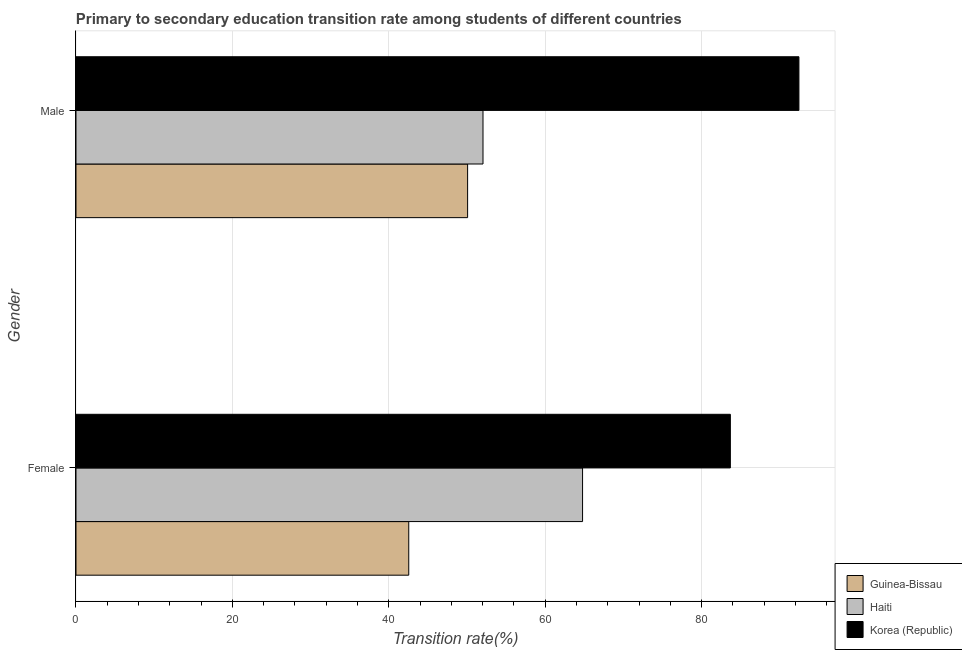Are the number of bars per tick equal to the number of legend labels?
Your answer should be compact. Yes. What is the transition rate among male students in Haiti?
Provide a succinct answer. 52.04. Across all countries, what is the maximum transition rate among male students?
Make the answer very short. 92.44. Across all countries, what is the minimum transition rate among female students?
Give a very brief answer. 42.55. In which country was the transition rate among male students minimum?
Provide a succinct answer. Guinea-Bissau. What is the total transition rate among female students in the graph?
Offer a very short reply. 191. What is the difference between the transition rate among male students in Korea (Republic) and that in Guinea-Bissau?
Offer a very short reply. 42.36. What is the difference between the transition rate among female students in Haiti and the transition rate among male students in Guinea-Bissau?
Provide a short and direct response. 14.7. What is the average transition rate among female students per country?
Make the answer very short. 63.67. What is the difference between the transition rate among female students and transition rate among male students in Korea (Republic)?
Make the answer very short. -8.77. What is the ratio of the transition rate among male students in Guinea-Bissau to that in Korea (Republic)?
Your response must be concise. 0.54. What does the 3rd bar from the top in Female represents?
Keep it short and to the point. Guinea-Bissau. How many bars are there?
Your answer should be very brief. 6. Are all the bars in the graph horizontal?
Provide a succinct answer. Yes. Does the graph contain any zero values?
Provide a short and direct response. No. Where does the legend appear in the graph?
Offer a terse response. Bottom right. How many legend labels are there?
Keep it short and to the point. 3. How are the legend labels stacked?
Give a very brief answer. Vertical. What is the title of the graph?
Your answer should be very brief. Primary to secondary education transition rate among students of different countries. Does "Iraq" appear as one of the legend labels in the graph?
Your answer should be compact. No. What is the label or title of the X-axis?
Your answer should be compact. Transition rate(%). What is the Transition rate(%) in Guinea-Bissau in Female?
Your answer should be compact. 42.55. What is the Transition rate(%) in Haiti in Female?
Ensure brevity in your answer.  64.77. What is the Transition rate(%) in Korea (Republic) in Female?
Give a very brief answer. 83.67. What is the Transition rate(%) of Guinea-Bissau in Male?
Provide a short and direct response. 50.08. What is the Transition rate(%) of Haiti in Male?
Offer a very short reply. 52.04. What is the Transition rate(%) of Korea (Republic) in Male?
Keep it short and to the point. 92.44. Across all Gender, what is the maximum Transition rate(%) in Guinea-Bissau?
Your answer should be very brief. 50.08. Across all Gender, what is the maximum Transition rate(%) of Haiti?
Your answer should be compact. 64.77. Across all Gender, what is the maximum Transition rate(%) in Korea (Republic)?
Your answer should be very brief. 92.44. Across all Gender, what is the minimum Transition rate(%) in Guinea-Bissau?
Provide a short and direct response. 42.55. Across all Gender, what is the minimum Transition rate(%) of Haiti?
Your answer should be compact. 52.04. Across all Gender, what is the minimum Transition rate(%) of Korea (Republic)?
Offer a terse response. 83.67. What is the total Transition rate(%) of Guinea-Bissau in the graph?
Keep it short and to the point. 92.63. What is the total Transition rate(%) of Haiti in the graph?
Ensure brevity in your answer.  116.82. What is the total Transition rate(%) in Korea (Republic) in the graph?
Make the answer very short. 176.11. What is the difference between the Transition rate(%) in Guinea-Bissau in Female and that in Male?
Ensure brevity in your answer.  -7.53. What is the difference between the Transition rate(%) in Haiti in Female and that in Male?
Make the answer very short. 12.73. What is the difference between the Transition rate(%) of Korea (Republic) in Female and that in Male?
Keep it short and to the point. -8.77. What is the difference between the Transition rate(%) of Guinea-Bissau in Female and the Transition rate(%) of Haiti in Male?
Your answer should be very brief. -9.49. What is the difference between the Transition rate(%) in Guinea-Bissau in Female and the Transition rate(%) in Korea (Republic) in Male?
Offer a terse response. -49.89. What is the difference between the Transition rate(%) in Haiti in Female and the Transition rate(%) in Korea (Republic) in Male?
Provide a short and direct response. -27.67. What is the average Transition rate(%) in Guinea-Bissau per Gender?
Make the answer very short. 46.31. What is the average Transition rate(%) of Haiti per Gender?
Your answer should be compact. 58.41. What is the average Transition rate(%) in Korea (Republic) per Gender?
Ensure brevity in your answer.  88.06. What is the difference between the Transition rate(%) of Guinea-Bissau and Transition rate(%) of Haiti in Female?
Your response must be concise. -22.22. What is the difference between the Transition rate(%) of Guinea-Bissau and Transition rate(%) of Korea (Republic) in Female?
Make the answer very short. -41.12. What is the difference between the Transition rate(%) in Haiti and Transition rate(%) in Korea (Republic) in Female?
Make the answer very short. -18.9. What is the difference between the Transition rate(%) of Guinea-Bissau and Transition rate(%) of Haiti in Male?
Offer a very short reply. -1.97. What is the difference between the Transition rate(%) in Guinea-Bissau and Transition rate(%) in Korea (Republic) in Male?
Your response must be concise. -42.36. What is the difference between the Transition rate(%) of Haiti and Transition rate(%) of Korea (Republic) in Male?
Offer a terse response. -40.4. What is the ratio of the Transition rate(%) in Guinea-Bissau in Female to that in Male?
Offer a terse response. 0.85. What is the ratio of the Transition rate(%) in Haiti in Female to that in Male?
Provide a succinct answer. 1.24. What is the ratio of the Transition rate(%) of Korea (Republic) in Female to that in Male?
Ensure brevity in your answer.  0.91. What is the difference between the highest and the second highest Transition rate(%) of Guinea-Bissau?
Ensure brevity in your answer.  7.53. What is the difference between the highest and the second highest Transition rate(%) in Haiti?
Provide a succinct answer. 12.73. What is the difference between the highest and the second highest Transition rate(%) of Korea (Republic)?
Ensure brevity in your answer.  8.77. What is the difference between the highest and the lowest Transition rate(%) in Guinea-Bissau?
Your answer should be very brief. 7.53. What is the difference between the highest and the lowest Transition rate(%) in Haiti?
Provide a short and direct response. 12.73. What is the difference between the highest and the lowest Transition rate(%) in Korea (Republic)?
Your response must be concise. 8.77. 